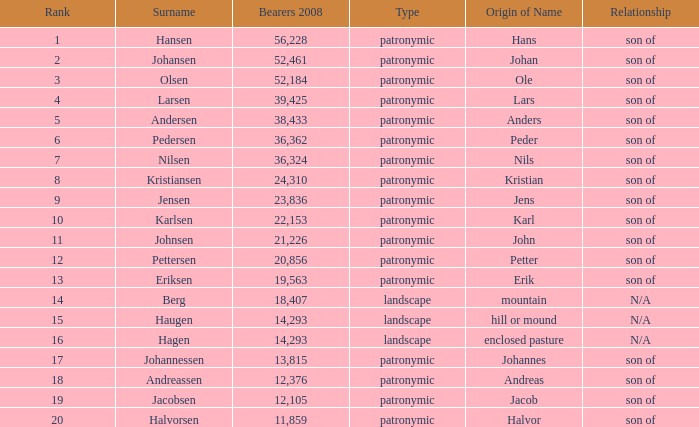What is Highest Number of Bearers 2008, when Surname is Jacobsen? 12.105. 